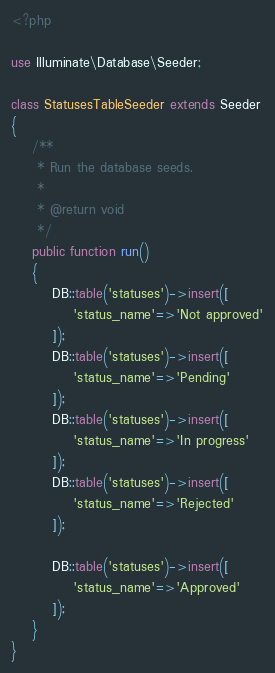<code> <loc_0><loc_0><loc_500><loc_500><_PHP_><?php

use Illuminate\Database\Seeder;

class StatusesTableSeeder extends Seeder
{
    /**
     * Run the database seeds.
     *
     * @return void
     */
    public function run()
    {
        DB::table('statuses')->insert([
            'status_name'=>'Not approved'
        ]);
        DB::table('statuses')->insert([
            'status_name'=>'Pending'
        ]);
        DB::table('statuses')->insert([
            'status_name'=>'In progress'
        ]);
        DB::table('statuses')->insert([
            'status_name'=>'Rejected'
        ]);

        DB::table('statuses')->insert([
            'status_name'=>'Approved'
        ]);
    }
}
</code> 